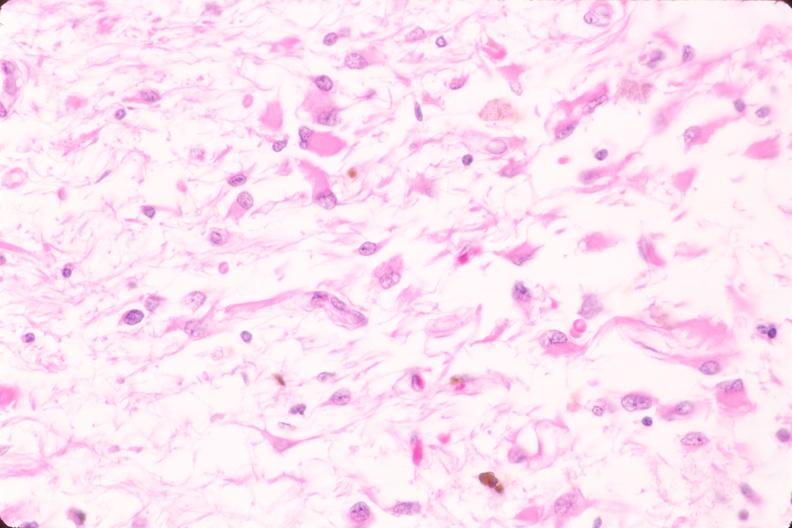what is present?
Answer the question using a single word or phrase. Nervous 